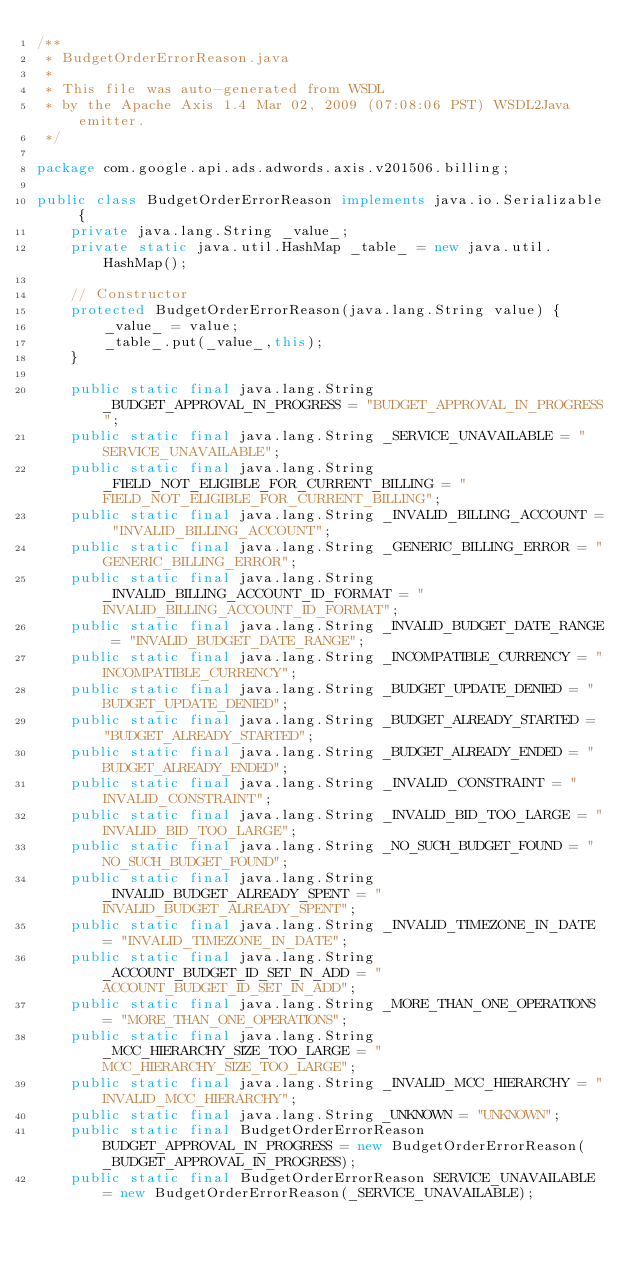<code> <loc_0><loc_0><loc_500><loc_500><_Java_>/**
 * BudgetOrderErrorReason.java
 *
 * This file was auto-generated from WSDL
 * by the Apache Axis 1.4 Mar 02, 2009 (07:08:06 PST) WSDL2Java emitter.
 */

package com.google.api.ads.adwords.axis.v201506.billing;

public class BudgetOrderErrorReason implements java.io.Serializable {
    private java.lang.String _value_;
    private static java.util.HashMap _table_ = new java.util.HashMap();

    // Constructor
    protected BudgetOrderErrorReason(java.lang.String value) {
        _value_ = value;
        _table_.put(_value_,this);
    }

    public static final java.lang.String _BUDGET_APPROVAL_IN_PROGRESS = "BUDGET_APPROVAL_IN_PROGRESS";
    public static final java.lang.String _SERVICE_UNAVAILABLE = "SERVICE_UNAVAILABLE";
    public static final java.lang.String _FIELD_NOT_ELIGIBLE_FOR_CURRENT_BILLING = "FIELD_NOT_ELIGIBLE_FOR_CURRENT_BILLING";
    public static final java.lang.String _INVALID_BILLING_ACCOUNT = "INVALID_BILLING_ACCOUNT";
    public static final java.lang.String _GENERIC_BILLING_ERROR = "GENERIC_BILLING_ERROR";
    public static final java.lang.String _INVALID_BILLING_ACCOUNT_ID_FORMAT = "INVALID_BILLING_ACCOUNT_ID_FORMAT";
    public static final java.lang.String _INVALID_BUDGET_DATE_RANGE = "INVALID_BUDGET_DATE_RANGE";
    public static final java.lang.String _INCOMPATIBLE_CURRENCY = "INCOMPATIBLE_CURRENCY";
    public static final java.lang.String _BUDGET_UPDATE_DENIED = "BUDGET_UPDATE_DENIED";
    public static final java.lang.String _BUDGET_ALREADY_STARTED = "BUDGET_ALREADY_STARTED";
    public static final java.lang.String _BUDGET_ALREADY_ENDED = "BUDGET_ALREADY_ENDED";
    public static final java.lang.String _INVALID_CONSTRAINT = "INVALID_CONSTRAINT";
    public static final java.lang.String _INVALID_BID_TOO_LARGE = "INVALID_BID_TOO_LARGE";
    public static final java.lang.String _NO_SUCH_BUDGET_FOUND = "NO_SUCH_BUDGET_FOUND";
    public static final java.lang.String _INVALID_BUDGET_ALREADY_SPENT = "INVALID_BUDGET_ALREADY_SPENT";
    public static final java.lang.String _INVALID_TIMEZONE_IN_DATE = "INVALID_TIMEZONE_IN_DATE";
    public static final java.lang.String _ACCOUNT_BUDGET_ID_SET_IN_ADD = "ACCOUNT_BUDGET_ID_SET_IN_ADD";
    public static final java.lang.String _MORE_THAN_ONE_OPERATIONS = "MORE_THAN_ONE_OPERATIONS";
    public static final java.lang.String _MCC_HIERARCHY_SIZE_TOO_LARGE = "MCC_HIERARCHY_SIZE_TOO_LARGE";
    public static final java.lang.String _INVALID_MCC_HIERARCHY = "INVALID_MCC_HIERARCHY";
    public static final java.lang.String _UNKNOWN = "UNKNOWN";
    public static final BudgetOrderErrorReason BUDGET_APPROVAL_IN_PROGRESS = new BudgetOrderErrorReason(_BUDGET_APPROVAL_IN_PROGRESS);
    public static final BudgetOrderErrorReason SERVICE_UNAVAILABLE = new BudgetOrderErrorReason(_SERVICE_UNAVAILABLE);</code> 